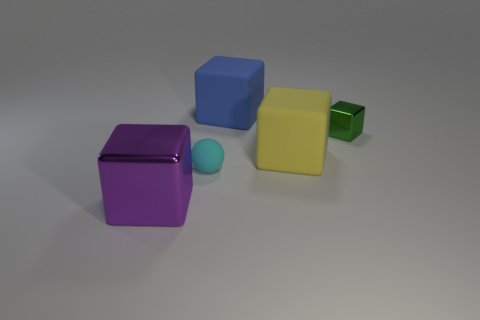Add 4 tiny shiny blocks. How many objects exist? 9 Subtract all blocks. How many objects are left? 1 Add 1 big shiny things. How many big shiny things are left? 2 Add 4 shiny blocks. How many shiny blocks exist? 6 Subtract 0 brown balls. How many objects are left? 5 Subtract all small purple shiny things. Subtract all large blue matte objects. How many objects are left? 4 